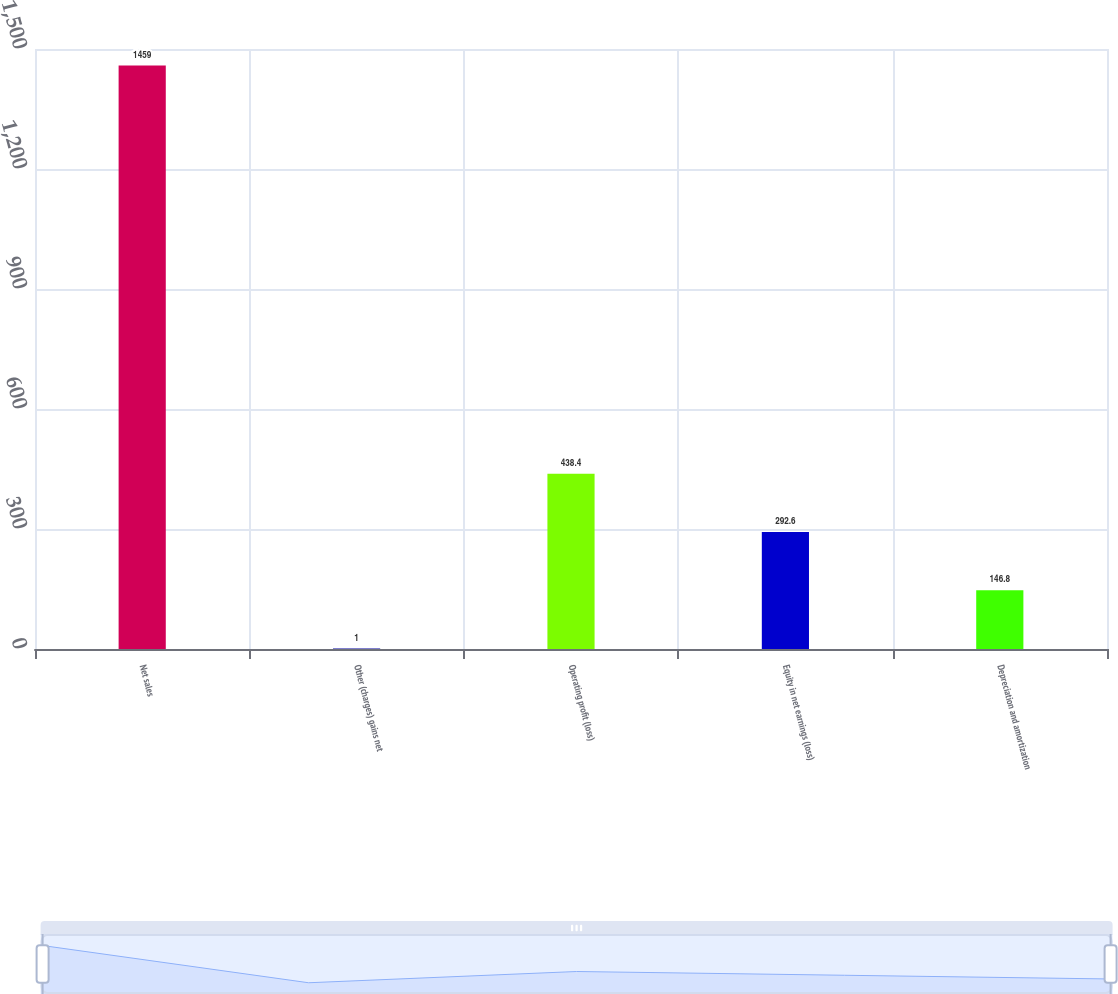Convert chart to OTSL. <chart><loc_0><loc_0><loc_500><loc_500><bar_chart><fcel>Net sales<fcel>Other (charges) gains net<fcel>Operating profit (loss)<fcel>Equity in net earnings (loss)<fcel>Depreciation and amortization<nl><fcel>1459<fcel>1<fcel>438.4<fcel>292.6<fcel>146.8<nl></chart> 